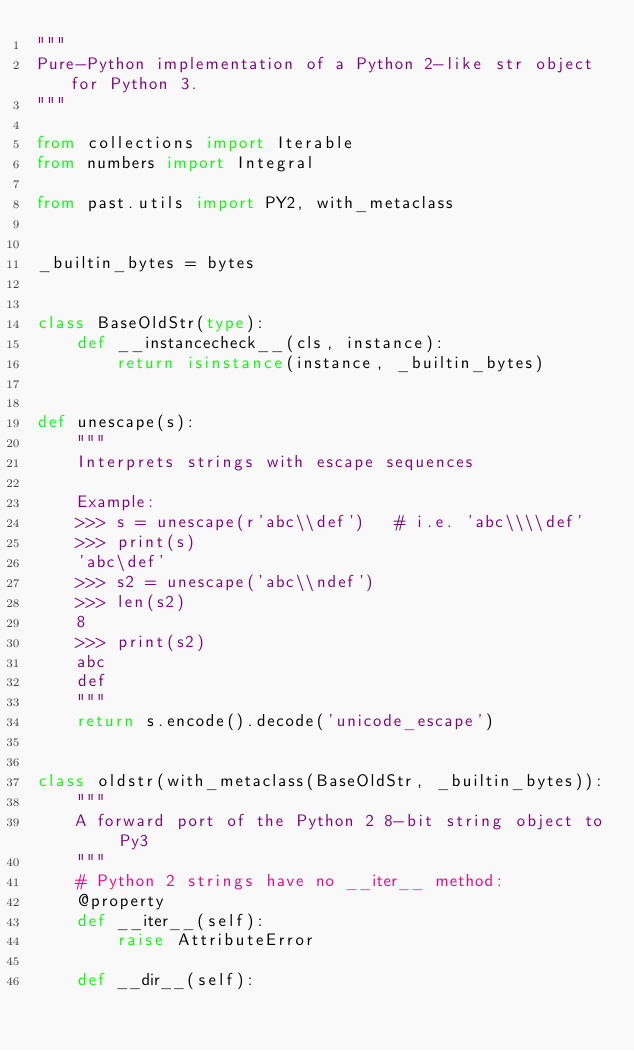<code> <loc_0><loc_0><loc_500><loc_500><_Python_>"""
Pure-Python implementation of a Python 2-like str object for Python 3.
"""

from collections import Iterable
from numbers import Integral

from past.utils import PY2, with_metaclass


_builtin_bytes = bytes


class BaseOldStr(type):
    def __instancecheck__(cls, instance):
        return isinstance(instance, _builtin_bytes)


def unescape(s):
    """
    Interprets strings with escape sequences

    Example:
    >>> s = unescape(r'abc\\def')   # i.e. 'abc\\\\def'
    >>> print(s)
    'abc\def'
    >>> s2 = unescape('abc\\ndef')
    >>> len(s2)
    8
    >>> print(s2)
    abc
    def
    """
    return s.encode().decode('unicode_escape')


class oldstr(with_metaclass(BaseOldStr, _builtin_bytes)):
    """
    A forward port of the Python 2 8-bit string object to Py3
    """
    # Python 2 strings have no __iter__ method:
    @property
    def __iter__(self):
        raise AttributeError

    def __dir__(self):</code> 